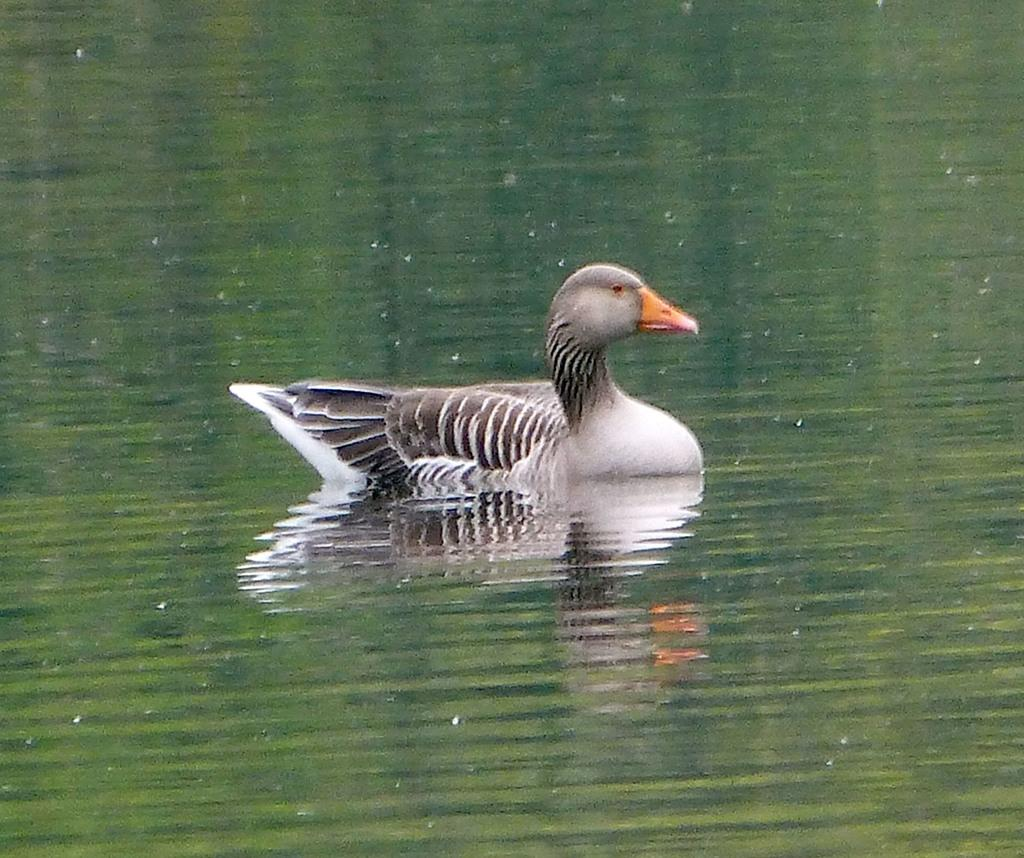What type of animal is in the image? There is a duck in the image. What colors are present on the duck? The duck is black and white. What color is the duck's beak? The duck has an orange beak. What is the duck doing in the image? The duck is swimming in the water. Is the duck acting as a spy in the image? There is no indication in the image that the duck is acting as a spy. Is the duck serving as a servant in the image? There is no indication in the image that the duck is serving as a servant. 